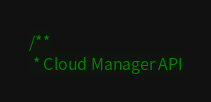Convert code to text. <code><loc_0><loc_0><loc_500><loc_500><_C_>/**
 * Cloud Manager API</code> 